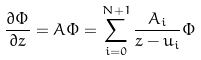<formula> <loc_0><loc_0><loc_500><loc_500>\frac { \partial \Phi } { \partial z } = A \Phi = \sum _ { i = 0 } ^ { N + 1 } \frac { A _ { i } } { z - u _ { i } } \Phi</formula> 